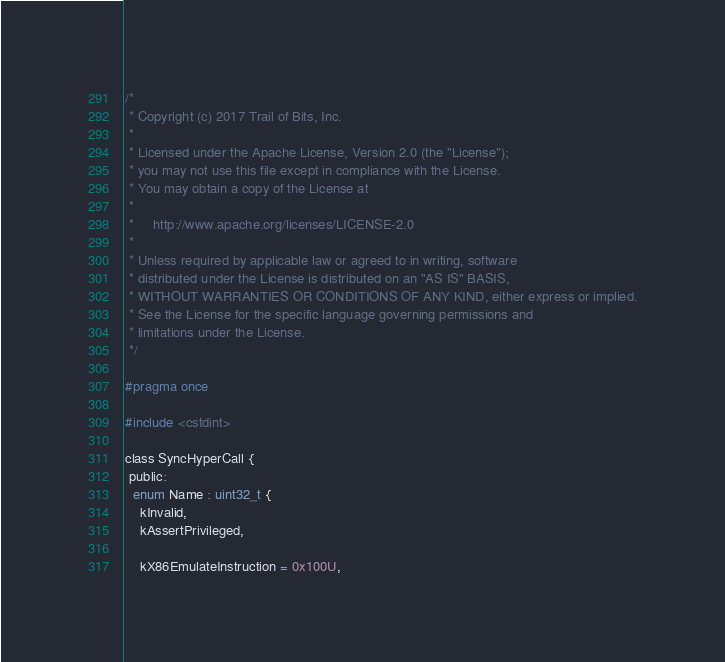Convert code to text. <code><loc_0><loc_0><loc_500><loc_500><_C_>/*
 * Copyright (c) 2017 Trail of Bits, Inc.
 *
 * Licensed under the Apache License, Version 2.0 (the "License");
 * you may not use this file except in compliance with the License.
 * You may obtain a copy of the License at
 *
 *     http://www.apache.org/licenses/LICENSE-2.0
 *
 * Unless required by applicable law or agreed to in writing, software
 * distributed under the License is distributed on an "AS IS" BASIS,
 * WITHOUT WARRANTIES OR CONDITIONS OF ANY KIND, either express or implied.
 * See the License for the specific language governing permissions and
 * limitations under the License.
 */

#pragma once

#include <cstdint>

class SyncHyperCall {
 public:
  enum Name : uint32_t {
    kInvalid,
    kAssertPrivileged,

    kX86EmulateInstruction = 0x100U,</code> 